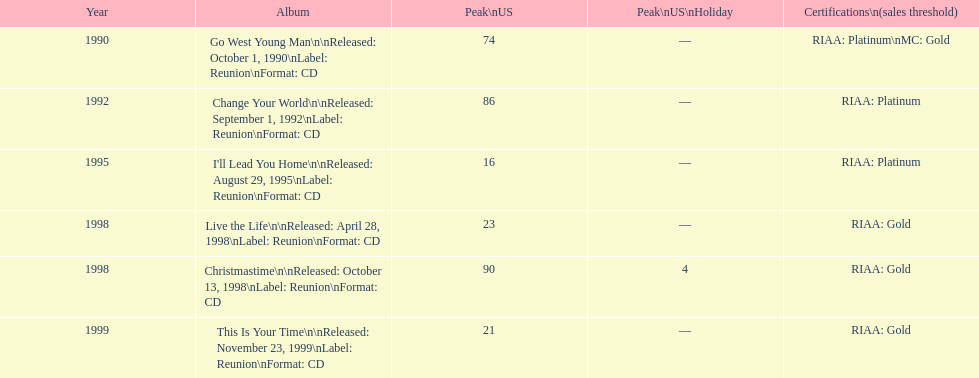Which album has the smallest peak in the us? I'll Lead You Home. 